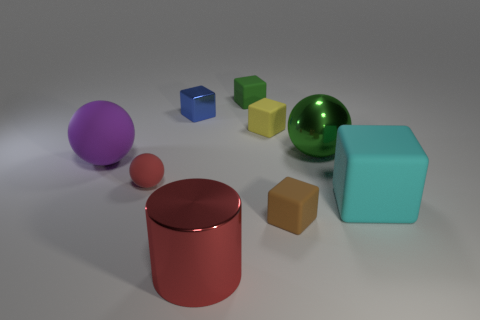There is a big cylinder that is made of the same material as the blue block; what color is it?
Provide a succinct answer. Red. Do the purple object and the sphere on the right side of the green matte block have the same material?
Offer a very short reply. No. The large rubber ball is what color?
Give a very brief answer. Purple. There is a brown cube that is made of the same material as the cyan cube; what is its size?
Your response must be concise. Small. What number of large matte balls are in front of the matte cube that is to the right of the large ball that is on the right side of the green matte cube?
Your response must be concise. 0. Do the large matte ball and the metallic thing that is in front of the small brown object have the same color?
Ensure brevity in your answer.  No. What shape is the object that is the same color as the tiny rubber ball?
Offer a very short reply. Cylinder. There is a block that is right of the ball that is to the right of the matte object that is behind the blue object; what is its material?
Provide a succinct answer. Rubber. Is the shape of the cyan rubber object that is right of the green sphere the same as  the green metal thing?
Keep it short and to the point. No. There is a sphere that is on the right side of the brown object; what is it made of?
Your answer should be very brief. Metal. 